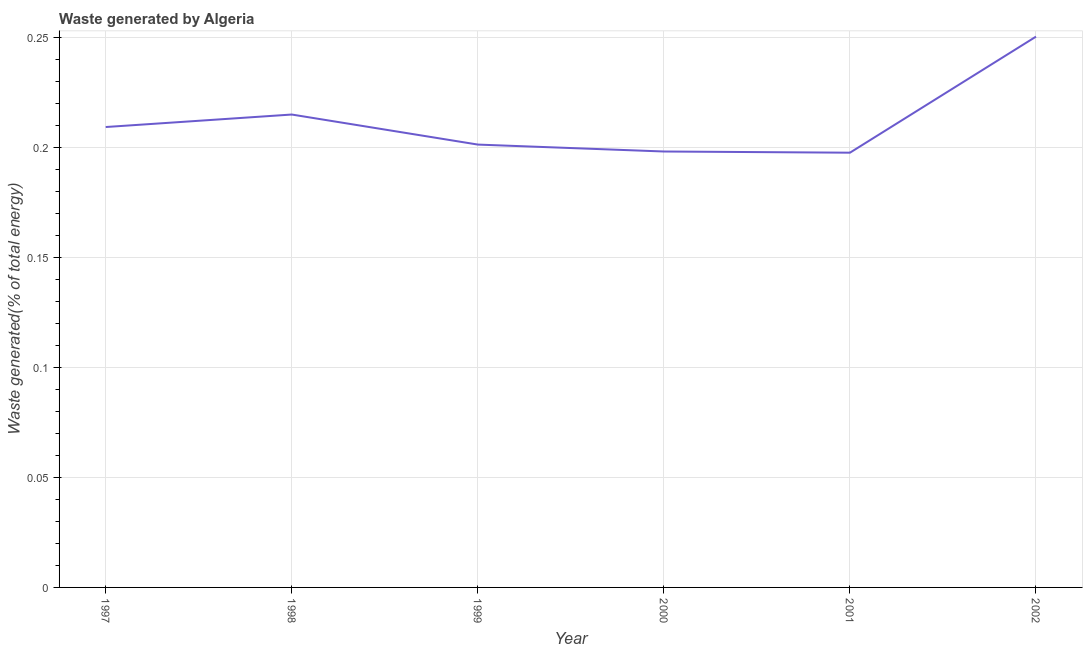What is the amount of waste generated in 2001?
Offer a very short reply. 0.2. Across all years, what is the maximum amount of waste generated?
Offer a very short reply. 0.25. Across all years, what is the minimum amount of waste generated?
Your answer should be compact. 0.2. In which year was the amount of waste generated maximum?
Your answer should be compact. 2002. In which year was the amount of waste generated minimum?
Ensure brevity in your answer.  2001. What is the sum of the amount of waste generated?
Your answer should be compact. 1.27. What is the difference between the amount of waste generated in 1999 and 2001?
Your answer should be compact. 0. What is the average amount of waste generated per year?
Make the answer very short. 0.21. What is the median amount of waste generated?
Offer a terse response. 0.21. Do a majority of the years between 2001 and 2000 (inclusive) have amount of waste generated greater than 0.17 %?
Make the answer very short. No. What is the ratio of the amount of waste generated in 1997 to that in 1999?
Provide a short and direct response. 1.04. What is the difference between the highest and the second highest amount of waste generated?
Offer a terse response. 0.04. What is the difference between the highest and the lowest amount of waste generated?
Provide a succinct answer. 0.05. In how many years, is the amount of waste generated greater than the average amount of waste generated taken over all years?
Give a very brief answer. 2. Does the amount of waste generated monotonically increase over the years?
Your answer should be compact. No. How many lines are there?
Ensure brevity in your answer.  1. How many years are there in the graph?
Your answer should be very brief. 6. What is the difference between two consecutive major ticks on the Y-axis?
Offer a terse response. 0.05. What is the title of the graph?
Make the answer very short. Waste generated by Algeria. What is the label or title of the X-axis?
Provide a short and direct response. Year. What is the label or title of the Y-axis?
Give a very brief answer. Waste generated(% of total energy). What is the Waste generated(% of total energy) of 1997?
Offer a terse response. 0.21. What is the Waste generated(% of total energy) in 1998?
Your answer should be very brief. 0.22. What is the Waste generated(% of total energy) in 1999?
Your response must be concise. 0.2. What is the Waste generated(% of total energy) in 2000?
Offer a very short reply. 0.2. What is the Waste generated(% of total energy) in 2001?
Your answer should be very brief. 0.2. What is the Waste generated(% of total energy) of 2002?
Offer a very short reply. 0.25. What is the difference between the Waste generated(% of total energy) in 1997 and 1998?
Provide a short and direct response. -0.01. What is the difference between the Waste generated(% of total energy) in 1997 and 1999?
Your answer should be compact. 0.01. What is the difference between the Waste generated(% of total energy) in 1997 and 2000?
Provide a succinct answer. 0.01. What is the difference between the Waste generated(% of total energy) in 1997 and 2001?
Your answer should be compact. 0.01. What is the difference between the Waste generated(% of total energy) in 1997 and 2002?
Your answer should be compact. -0.04. What is the difference between the Waste generated(% of total energy) in 1998 and 1999?
Keep it short and to the point. 0.01. What is the difference between the Waste generated(% of total energy) in 1998 and 2000?
Offer a terse response. 0.02. What is the difference between the Waste generated(% of total energy) in 1998 and 2001?
Provide a succinct answer. 0.02. What is the difference between the Waste generated(% of total energy) in 1998 and 2002?
Your answer should be very brief. -0.04. What is the difference between the Waste generated(% of total energy) in 1999 and 2000?
Ensure brevity in your answer.  0. What is the difference between the Waste generated(% of total energy) in 1999 and 2001?
Make the answer very short. 0. What is the difference between the Waste generated(% of total energy) in 1999 and 2002?
Give a very brief answer. -0.05. What is the difference between the Waste generated(% of total energy) in 2000 and 2001?
Keep it short and to the point. 0. What is the difference between the Waste generated(% of total energy) in 2000 and 2002?
Ensure brevity in your answer.  -0.05. What is the difference between the Waste generated(% of total energy) in 2001 and 2002?
Your response must be concise. -0.05. What is the ratio of the Waste generated(% of total energy) in 1997 to that in 2000?
Provide a short and direct response. 1.06. What is the ratio of the Waste generated(% of total energy) in 1997 to that in 2001?
Offer a very short reply. 1.06. What is the ratio of the Waste generated(% of total energy) in 1997 to that in 2002?
Keep it short and to the point. 0.84. What is the ratio of the Waste generated(% of total energy) in 1998 to that in 1999?
Ensure brevity in your answer.  1.07. What is the ratio of the Waste generated(% of total energy) in 1998 to that in 2000?
Ensure brevity in your answer.  1.08. What is the ratio of the Waste generated(% of total energy) in 1998 to that in 2001?
Give a very brief answer. 1.09. What is the ratio of the Waste generated(% of total energy) in 1998 to that in 2002?
Give a very brief answer. 0.86. What is the ratio of the Waste generated(% of total energy) in 1999 to that in 2002?
Provide a short and direct response. 0.8. What is the ratio of the Waste generated(% of total energy) in 2000 to that in 2001?
Provide a succinct answer. 1. What is the ratio of the Waste generated(% of total energy) in 2000 to that in 2002?
Give a very brief answer. 0.79. What is the ratio of the Waste generated(% of total energy) in 2001 to that in 2002?
Your response must be concise. 0.79. 